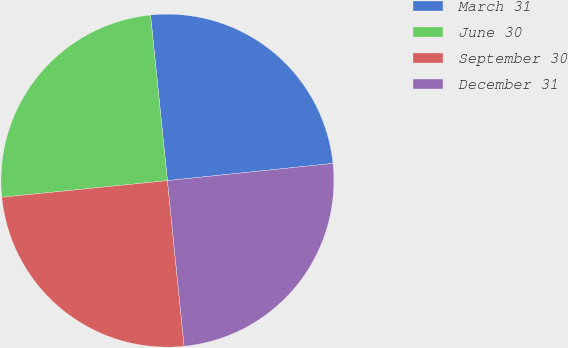Convert chart to OTSL. <chart><loc_0><loc_0><loc_500><loc_500><pie_chart><fcel>March 31<fcel>June 30<fcel>September 30<fcel>December 31<nl><fcel>24.97%<fcel>24.98%<fcel>25.01%<fcel>25.05%<nl></chart> 